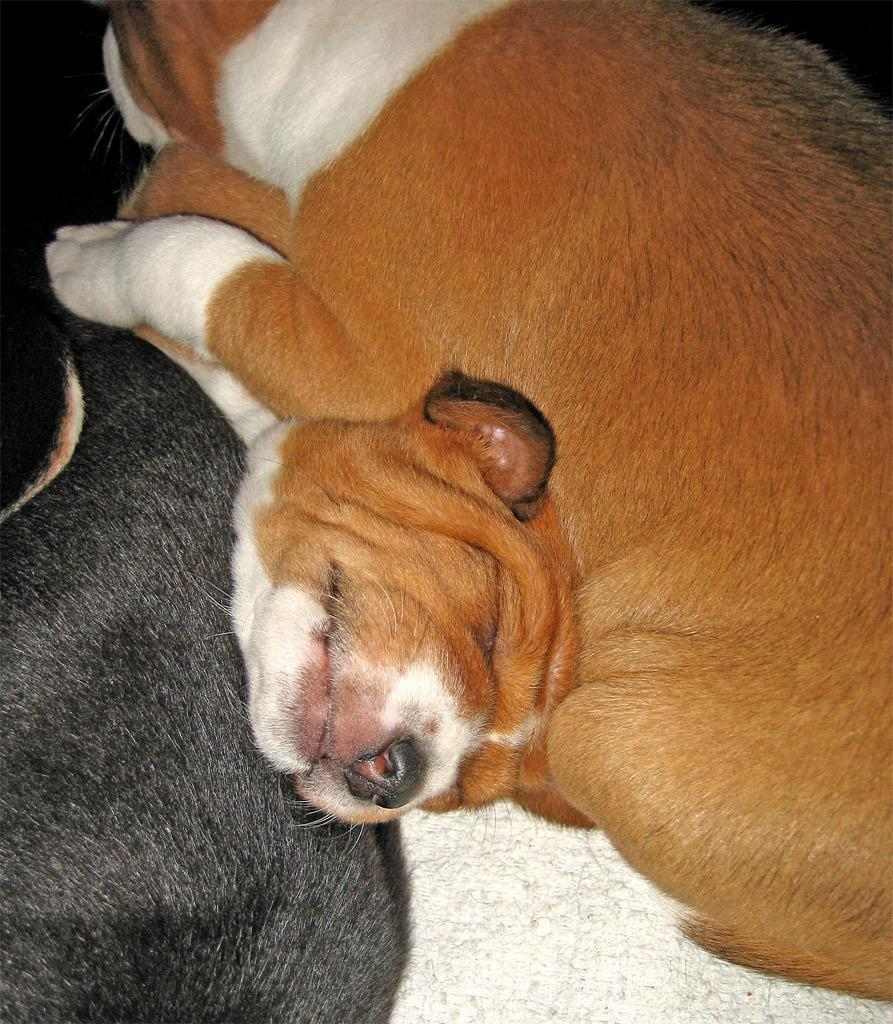What type of animals are present in the image? There are dogs in the image. What type of pot is visible in the image? There is no pot present in the image; it only features dogs. What is the temperature of the sun in the image? The image does not depict the sun, so we cannot determine its temperature. 